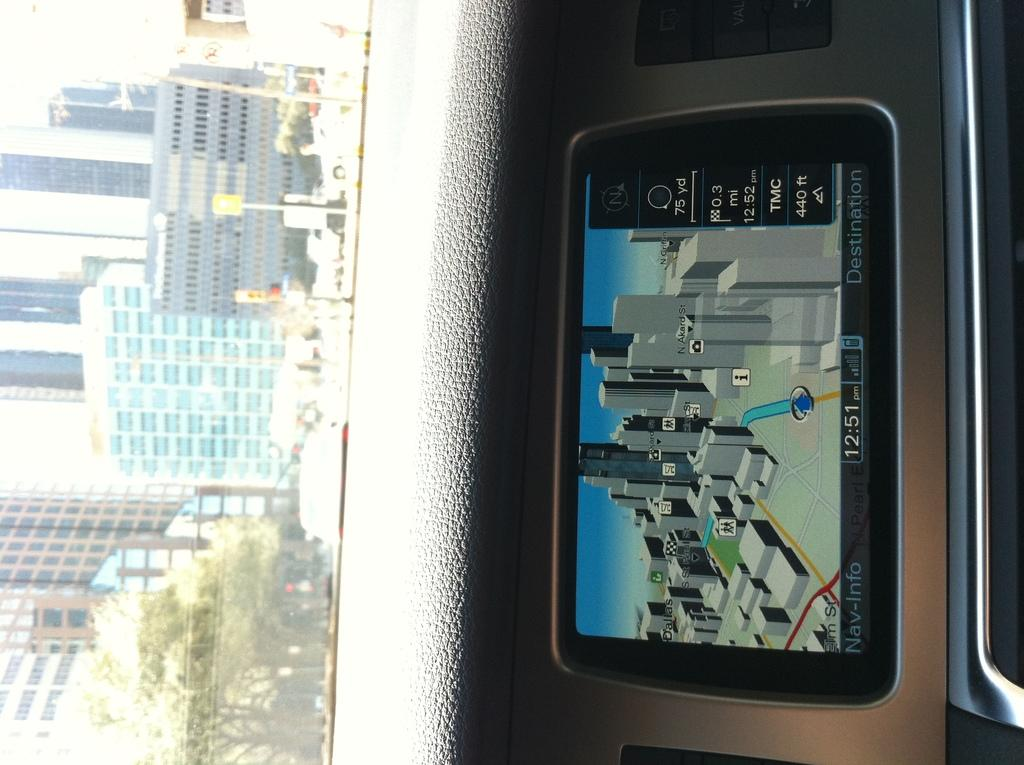Provide a one-sentence caption for the provided image. A navigation image of a city on a Nav-Info device on a dashboard with a city scape outside the window. 